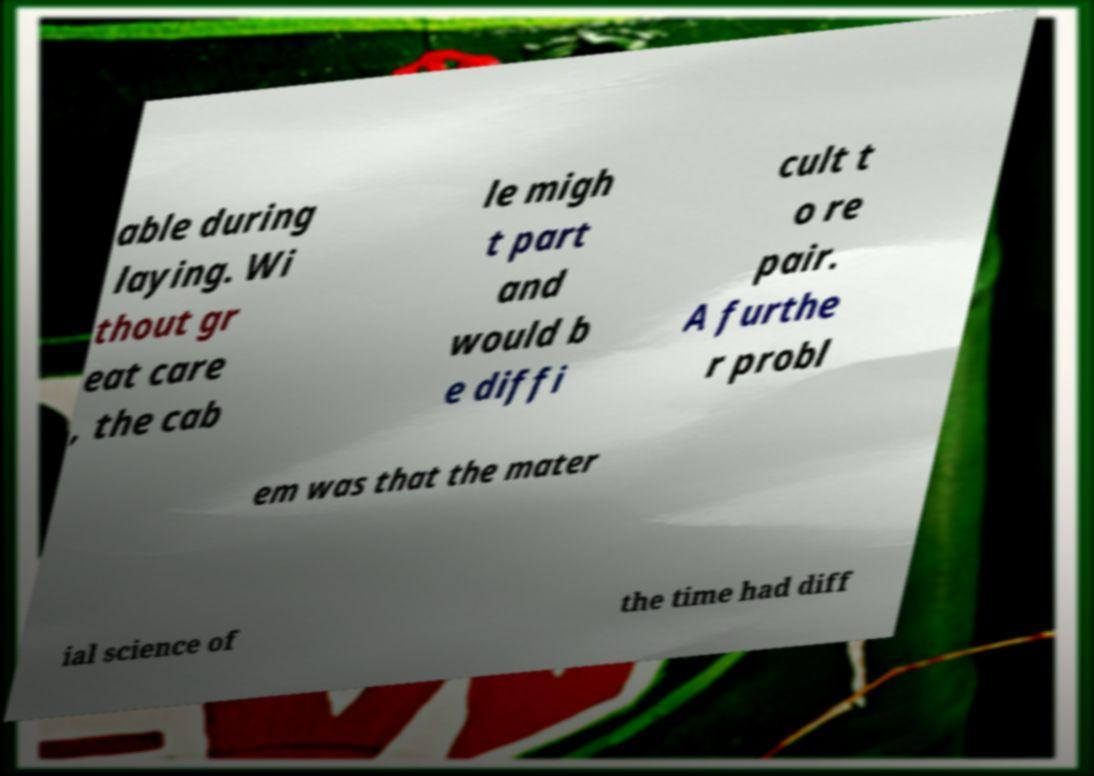There's text embedded in this image that I need extracted. Can you transcribe it verbatim? able during laying. Wi thout gr eat care , the cab le migh t part and would b e diffi cult t o re pair. A furthe r probl em was that the mater ial science of the time had diff 